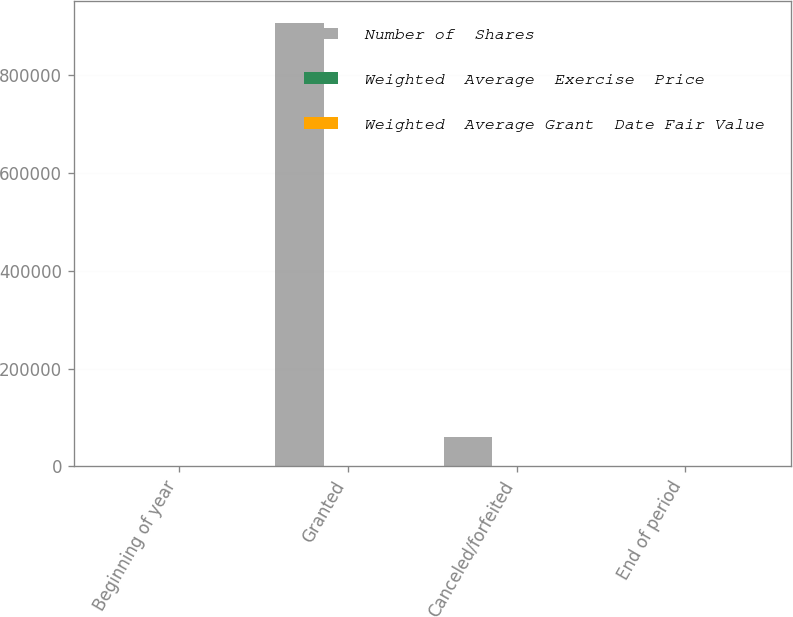Convert chart to OTSL. <chart><loc_0><loc_0><loc_500><loc_500><stacked_bar_chart><ecel><fcel>Beginning of year<fcel>Granted<fcel>Canceled/forfeited<fcel>End of period<nl><fcel>Number of  Shares<fcel>24.185<fcel>906600<fcel>60225<fcel>24.185<nl><fcel>Weighted  Average  Exercise  Price<fcel>21.68<fcel>43.69<fcel>32.46<fcel>26.69<nl><fcel>Weighted  Average Grant  Date Fair Value<fcel>9.41<fcel>10.46<fcel>10.01<fcel>10.27<nl></chart> 